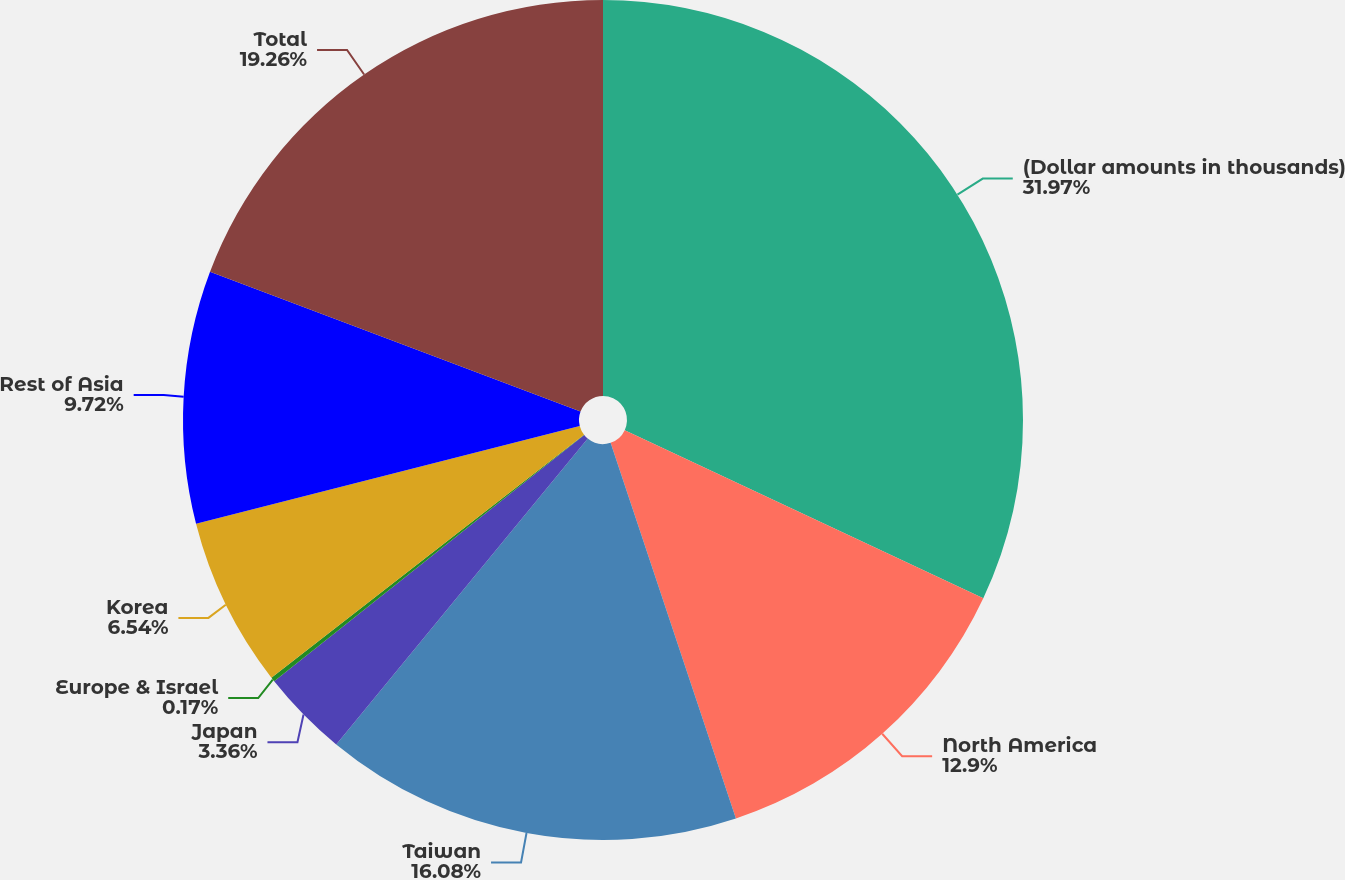<chart> <loc_0><loc_0><loc_500><loc_500><pie_chart><fcel>(Dollar amounts in thousands)<fcel>North America<fcel>Taiwan<fcel>Japan<fcel>Europe & Israel<fcel>Korea<fcel>Rest of Asia<fcel>Total<nl><fcel>31.98%<fcel>12.9%<fcel>16.08%<fcel>3.36%<fcel>0.17%<fcel>6.54%<fcel>9.72%<fcel>19.26%<nl></chart> 